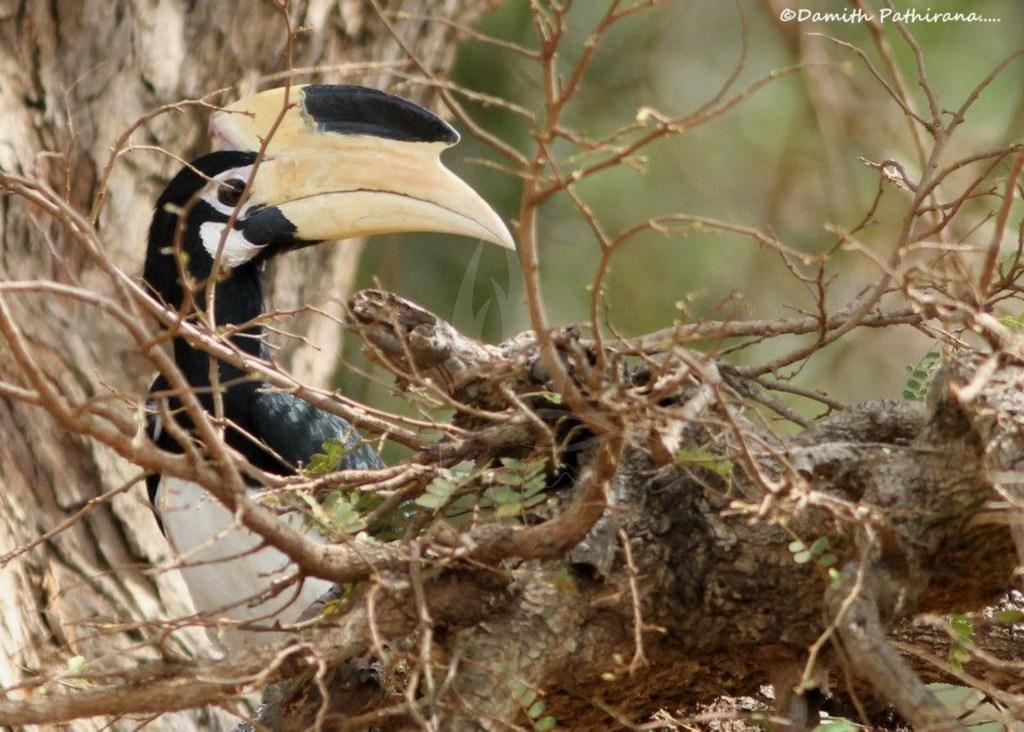What type of animal can be seen in the image? There is a bird in the image. Where is the bird located in the image? The bird is sitting on a branch of a tree. In which direction is the bird looking? The bird is looking in a particular direction. What letters can be seen on the bird's wings in the image? There are no letters visible on the bird's wings in the image. 